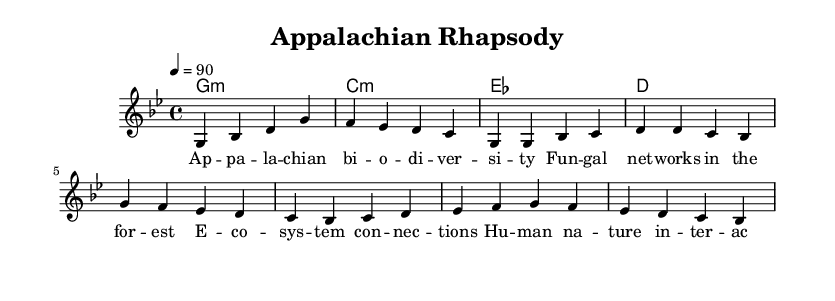What is the key signature of this music? The key signature is G minor, which has two flats (B flat and E flat). This can be identified by looking at the key signature at the beginning of the staff.
Answer: G minor What is the time signature of this piece? The time signature is 4/4, indicated at the beginning of the music, which means there are four beats in each measure and the quarter note gets one beat.
Answer: 4/4 What is the tempo marking? The tempo marking is 90 beats per minute, as indicated by the marking "4 = 90" at the start of the piece. This means each quarter note will be played at a rate of 90 beats per minute.
Answer: 90 How many measures are in the chorus? The chorus consists of 4 measures, which can be counted by looking at the section labeled "Chorus" and counting the individual measures present.
Answer: 4 What is the harmony used in the first measure? The harmony used in the first measure is G minor, as indicated by the chord at the beginning of the score in the chord names section, which shows the structure that will accompany the melody.
Answer: G minor Why is the title significant to the music style? The title "Appalachian Rhapsody" signifies a blend of elements from traditional Appalachian music and modern hip hop, reflecting the thematic integration of local flora and fauna sounds in the experimental rap genre. This shows the cultural influence and connection to the region.
Answer: Appalachian Rhapsody What type of lyrics are present in this piece? The lyrics are thematic and descriptive, focusing on nature and ecology, which aligns with the overall theme of the music combining Appalachian sounds and hip hop elements. They include references to biodiversity and ecosystems.
Answer: Thematic 